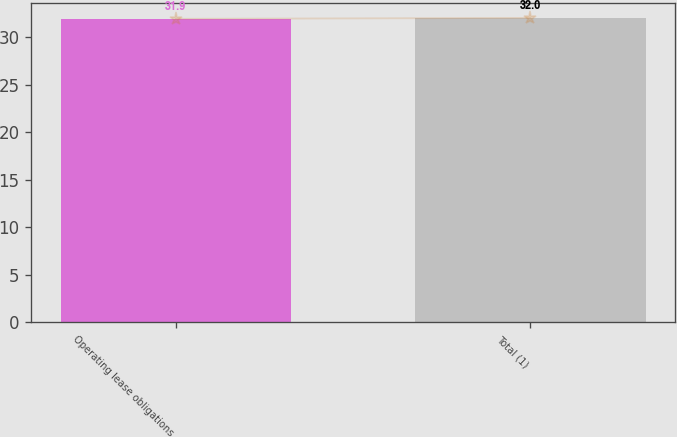Convert chart to OTSL. <chart><loc_0><loc_0><loc_500><loc_500><bar_chart><fcel>Operating lease obligations<fcel>Total (1)<nl><fcel>31.9<fcel>32<nl></chart> 